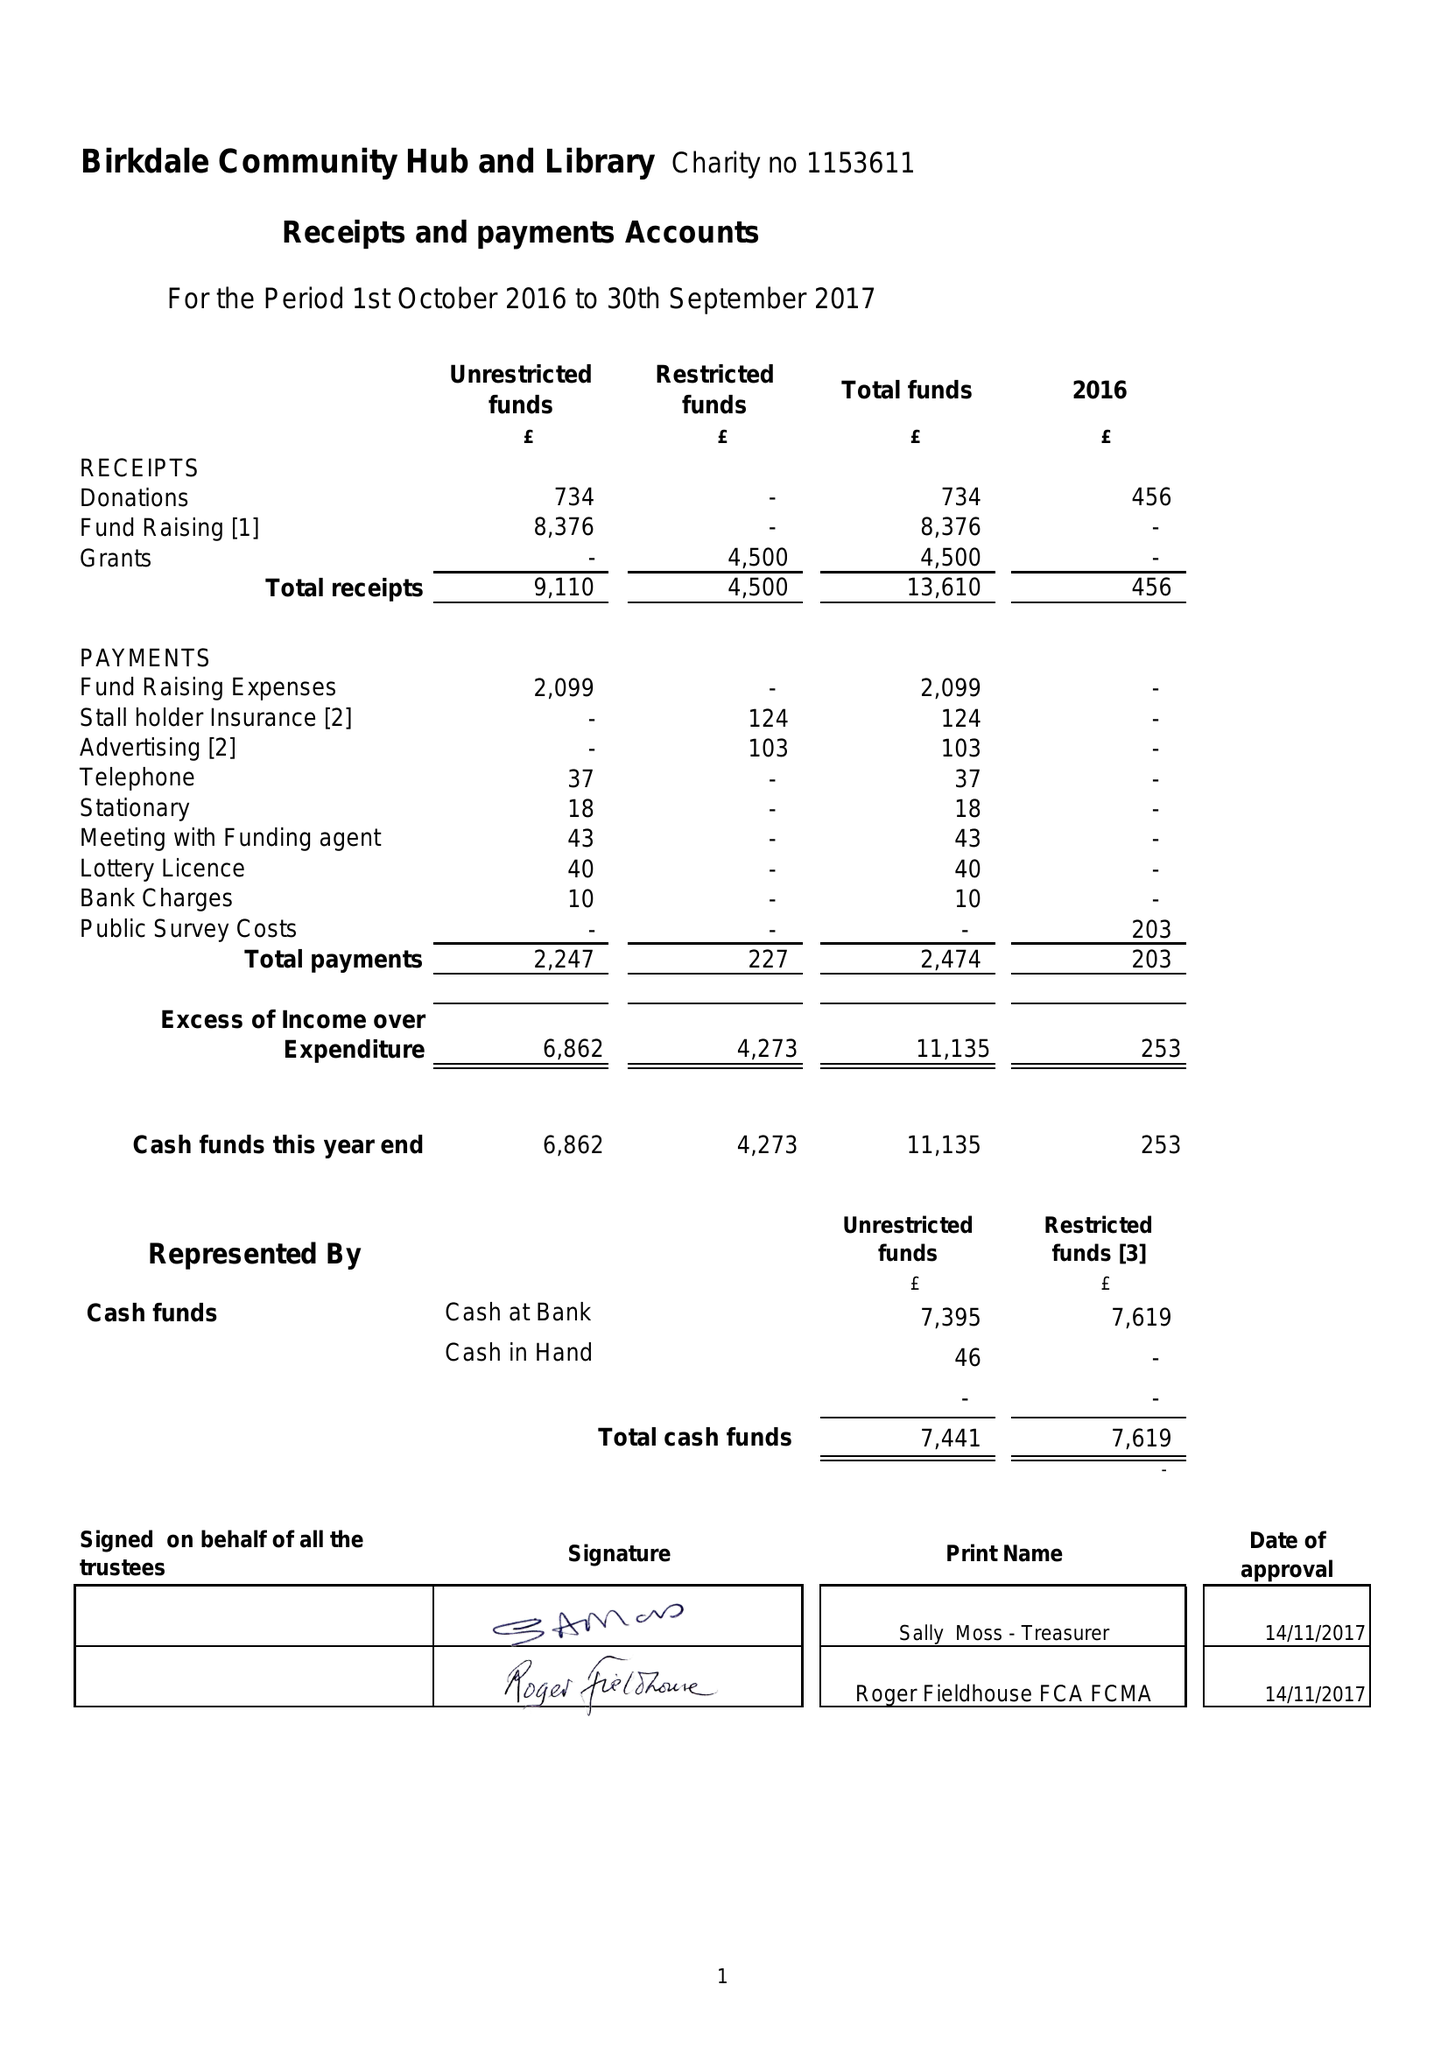What is the value for the report_date?
Answer the question using a single word or phrase. 2017-09-30 